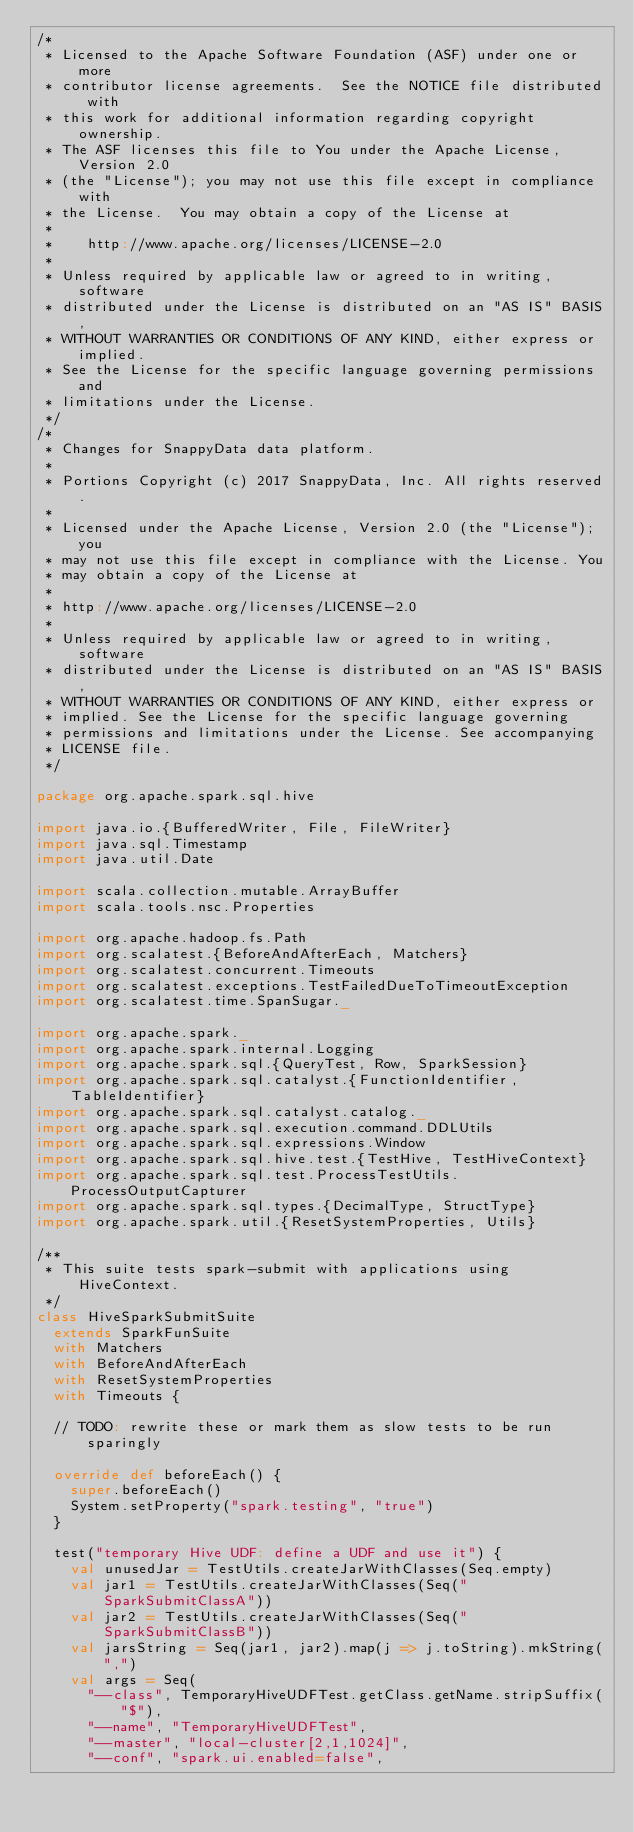<code> <loc_0><loc_0><loc_500><loc_500><_Scala_>/*
 * Licensed to the Apache Software Foundation (ASF) under one or more
 * contributor license agreements.  See the NOTICE file distributed with
 * this work for additional information regarding copyright ownership.
 * The ASF licenses this file to You under the Apache License, Version 2.0
 * (the "License"); you may not use this file except in compliance with
 * the License.  You may obtain a copy of the License at
 *
 *    http://www.apache.org/licenses/LICENSE-2.0
 *
 * Unless required by applicable law or agreed to in writing, software
 * distributed under the License is distributed on an "AS IS" BASIS,
 * WITHOUT WARRANTIES OR CONDITIONS OF ANY KIND, either express or implied.
 * See the License for the specific language governing permissions and
 * limitations under the License.
 */
/*
 * Changes for SnappyData data platform.
 *
 * Portions Copyright (c) 2017 SnappyData, Inc. All rights reserved.
 *
 * Licensed under the Apache License, Version 2.0 (the "License"); you
 * may not use this file except in compliance with the License. You
 * may obtain a copy of the License at
 *
 * http://www.apache.org/licenses/LICENSE-2.0
 *
 * Unless required by applicable law or agreed to in writing, software
 * distributed under the License is distributed on an "AS IS" BASIS,
 * WITHOUT WARRANTIES OR CONDITIONS OF ANY KIND, either express or
 * implied. See the License for the specific language governing
 * permissions and limitations under the License. See accompanying
 * LICENSE file.
 */

package org.apache.spark.sql.hive

import java.io.{BufferedWriter, File, FileWriter}
import java.sql.Timestamp
import java.util.Date

import scala.collection.mutable.ArrayBuffer
import scala.tools.nsc.Properties

import org.apache.hadoop.fs.Path
import org.scalatest.{BeforeAndAfterEach, Matchers}
import org.scalatest.concurrent.Timeouts
import org.scalatest.exceptions.TestFailedDueToTimeoutException
import org.scalatest.time.SpanSugar._

import org.apache.spark._
import org.apache.spark.internal.Logging
import org.apache.spark.sql.{QueryTest, Row, SparkSession}
import org.apache.spark.sql.catalyst.{FunctionIdentifier, TableIdentifier}
import org.apache.spark.sql.catalyst.catalog._
import org.apache.spark.sql.execution.command.DDLUtils
import org.apache.spark.sql.expressions.Window
import org.apache.spark.sql.hive.test.{TestHive, TestHiveContext}
import org.apache.spark.sql.test.ProcessTestUtils.ProcessOutputCapturer
import org.apache.spark.sql.types.{DecimalType, StructType}
import org.apache.spark.util.{ResetSystemProperties, Utils}

/**
 * This suite tests spark-submit with applications using HiveContext.
 */
class HiveSparkSubmitSuite
  extends SparkFunSuite
  with Matchers
  with BeforeAndAfterEach
  with ResetSystemProperties
  with Timeouts {

  // TODO: rewrite these or mark them as slow tests to be run sparingly

  override def beforeEach() {
    super.beforeEach()
    System.setProperty("spark.testing", "true")
  }

  test("temporary Hive UDF: define a UDF and use it") {
    val unusedJar = TestUtils.createJarWithClasses(Seq.empty)
    val jar1 = TestUtils.createJarWithClasses(Seq("SparkSubmitClassA"))
    val jar2 = TestUtils.createJarWithClasses(Seq("SparkSubmitClassB"))
    val jarsString = Seq(jar1, jar2).map(j => j.toString).mkString(",")
    val args = Seq(
      "--class", TemporaryHiveUDFTest.getClass.getName.stripSuffix("$"),
      "--name", "TemporaryHiveUDFTest",
      "--master", "local-cluster[2,1,1024]",
      "--conf", "spark.ui.enabled=false",</code> 